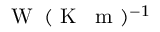Convert formula to latex. <formula><loc_0><loc_0><loc_500><loc_500>W \, ( K \, m ) ^ { - 1 }</formula> 